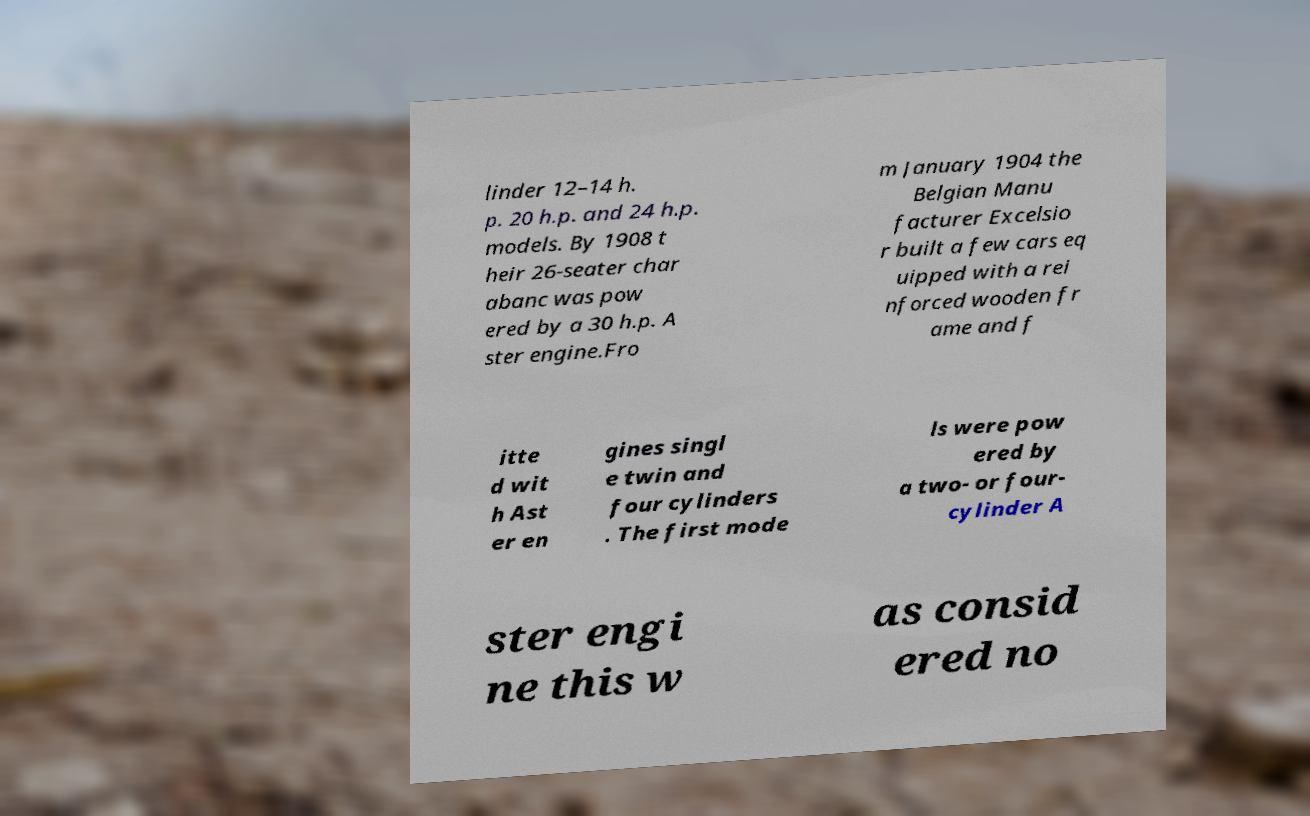Could you extract and type out the text from this image? linder 12–14 h. p. 20 h.p. and 24 h.p. models. By 1908 t heir 26-seater char abanc was pow ered by a 30 h.p. A ster engine.Fro m January 1904 the Belgian Manu facturer Excelsio r built a few cars eq uipped with a rei nforced wooden fr ame and f itte d wit h Ast er en gines singl e twin and four cylinders . The first mode ls were pow ered by a two- or four- cylinder A ster engi ne this w as consid ered no 